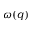Convert formula to latex. <formula><loc_0><loc_0><loc_500><loc_500>\omega ( q )</formula> 